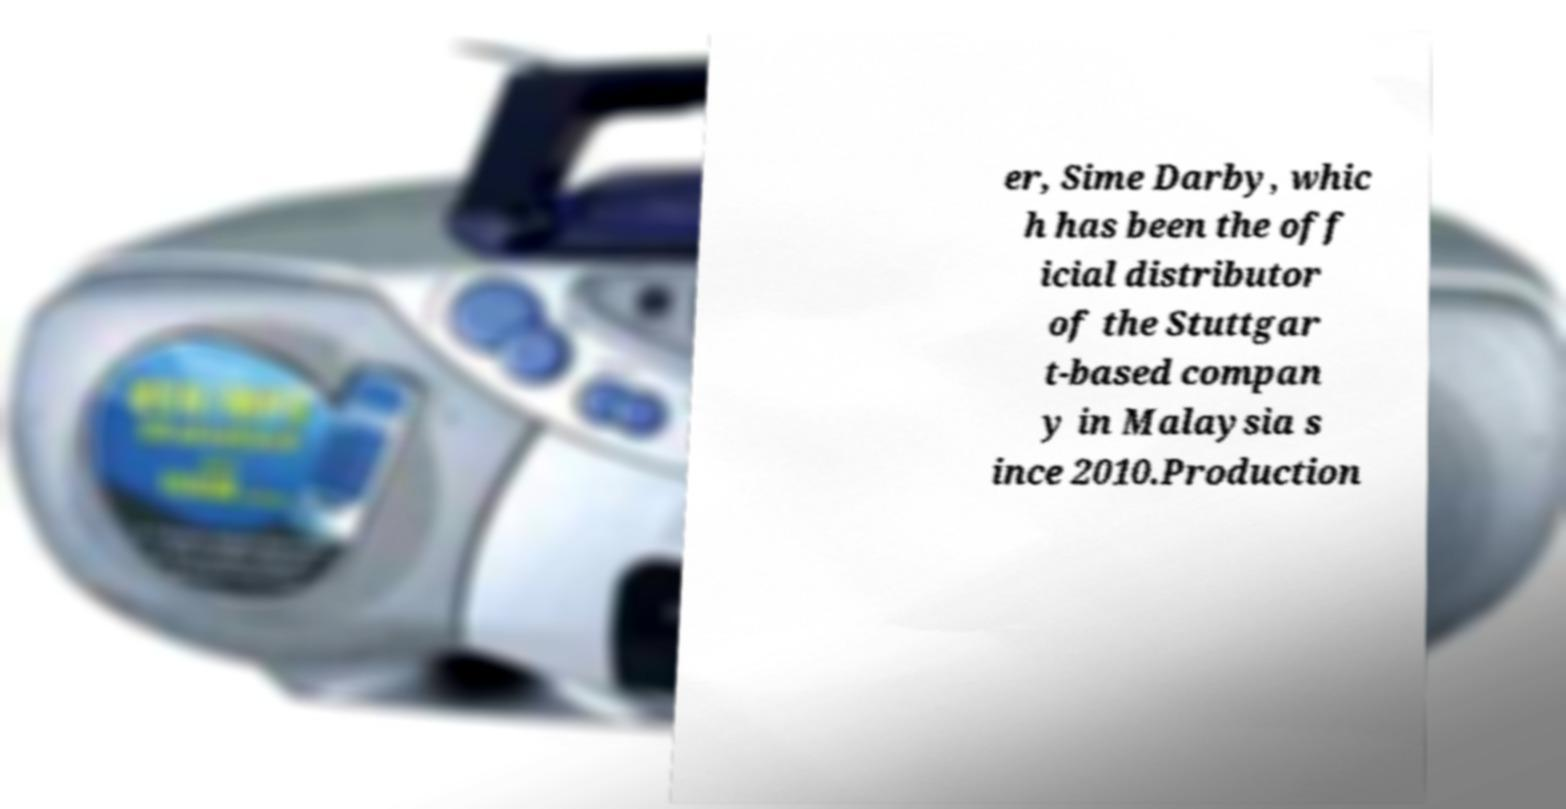Could you extract and type out the text from this image? er, Sime Darby, whic h has been the off icial distributor of the Stuttgar t-based compan y in Malaysia s ince 2010.Production 